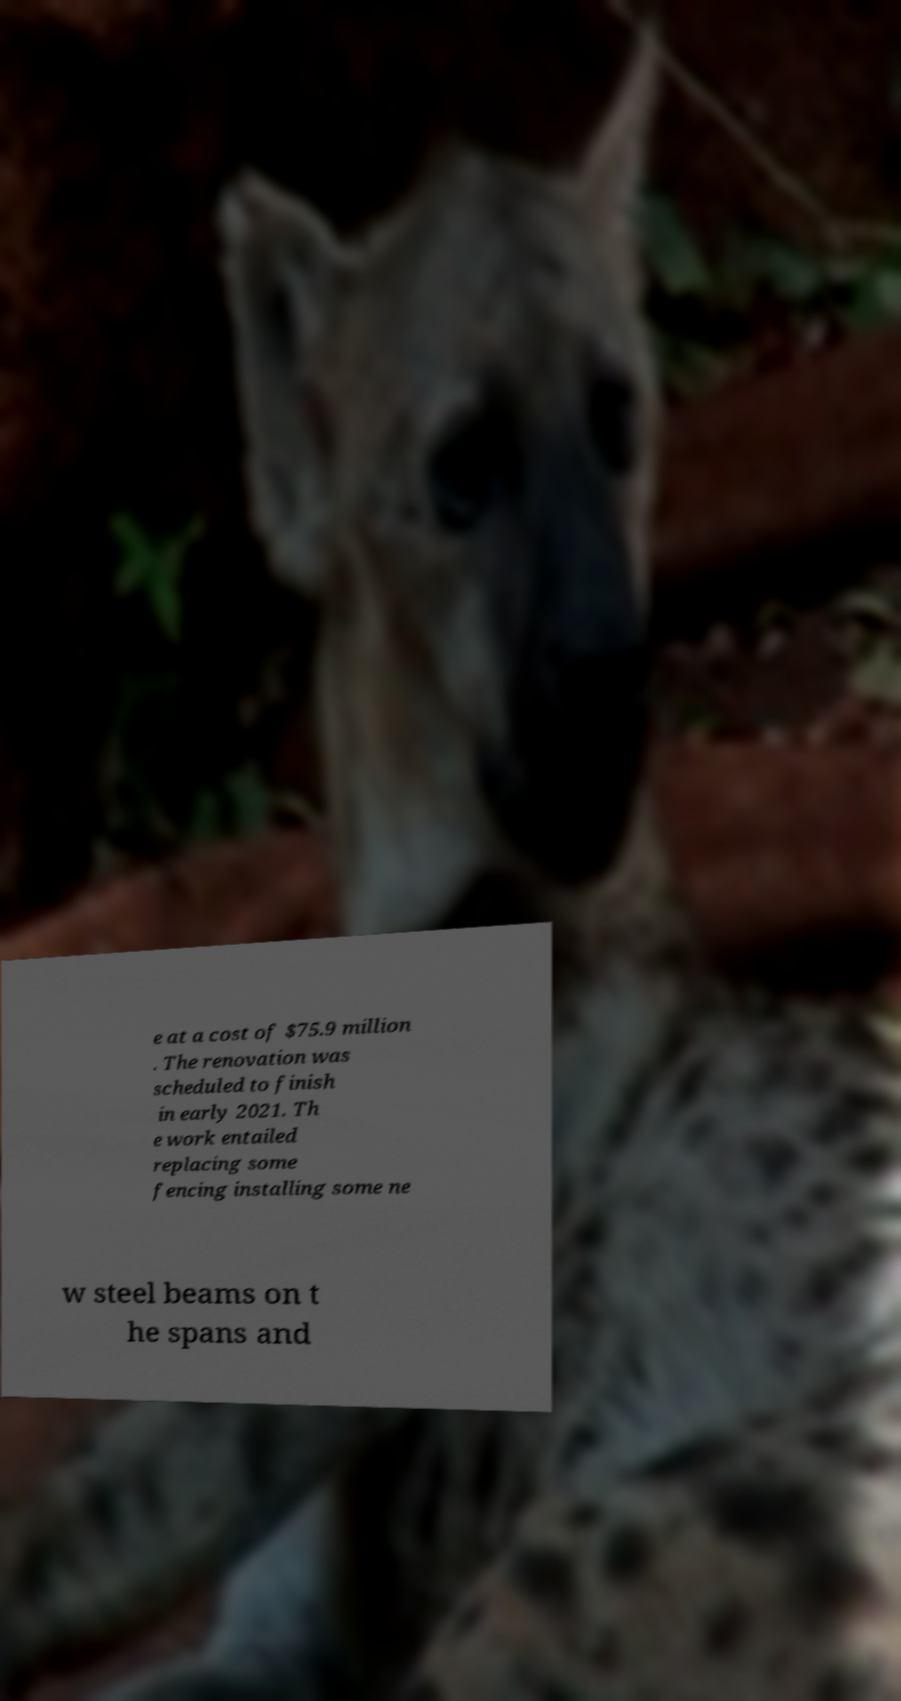Can you read and provide the text displayed in the image?This photo seems to have some interesting text. Can you extract and type it out for me? e at a cost of $75.9 million . The renovation was scheduled to finish in early 2021. Th e work entailed replacing some fencing installing some ne w steel beams on t he spans and 